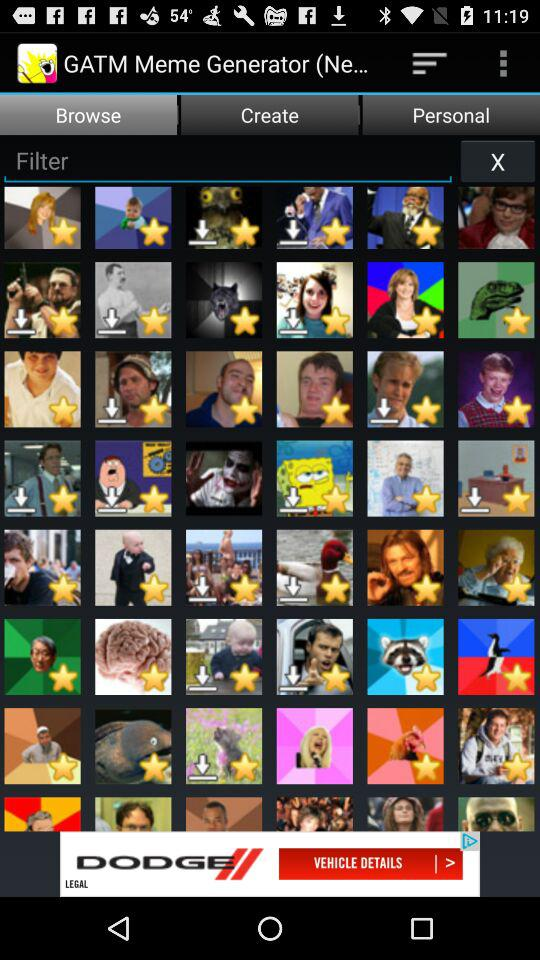What is the app title? The app title is "GATM Meme Generator (Ne...". 